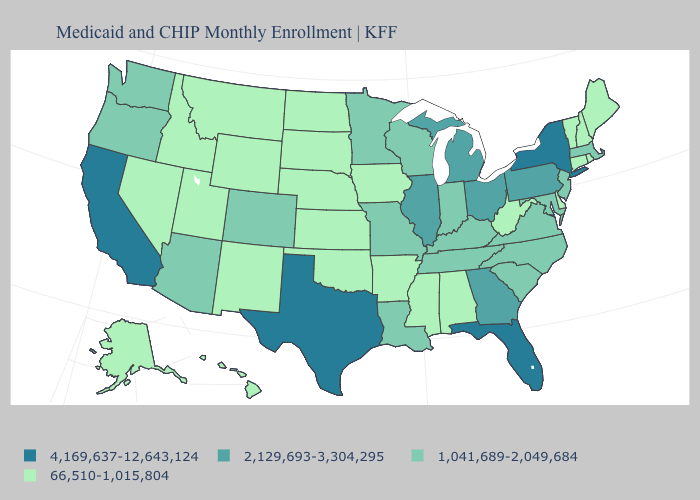How many symbols are there in the legend?
Be succinct. 4. Name the states that have a value in the range 4,169,637-12,643,124?
Concise answer only. California, Florida, New York, Texas. Does the first symbol in the legend represent the smallest category?
Write a very short answer. No. How many symbols are there in the legend?
Keep it brief. 4. What is the value of Delaware?
Write a very short answer. 66,510-1,015,804. What is the value of Idaho?
Give a very brief answer. 66,510-1,015,804. Name the states that have a value in the range 4,169,637-12,643,124?
Give a very brief answer. California, Florida, New York, Texas. What is the lowest value in states that border Vermont?
Write a very short answer. 66,510-1,015,804. What is the value of Nevada?
Short answer required. 66,510-1,015,804. Among the states that border Iowa , does Nebraska have the highest value?
Be succinct. No. Which states hav the highest value in the South?
Answer briefly. Florida, Texas. What is the value of Nevada?
Quick response, please. 66,510-1,015,804. What is the value of Nebraska?
Concise answer only. 66,510-1,015,804. What is the lowest value in the USA?
Answer briefly. 66,510-1,015,804. Does Colorado have the same value as Oklahoma?
Concise answer only. No. 